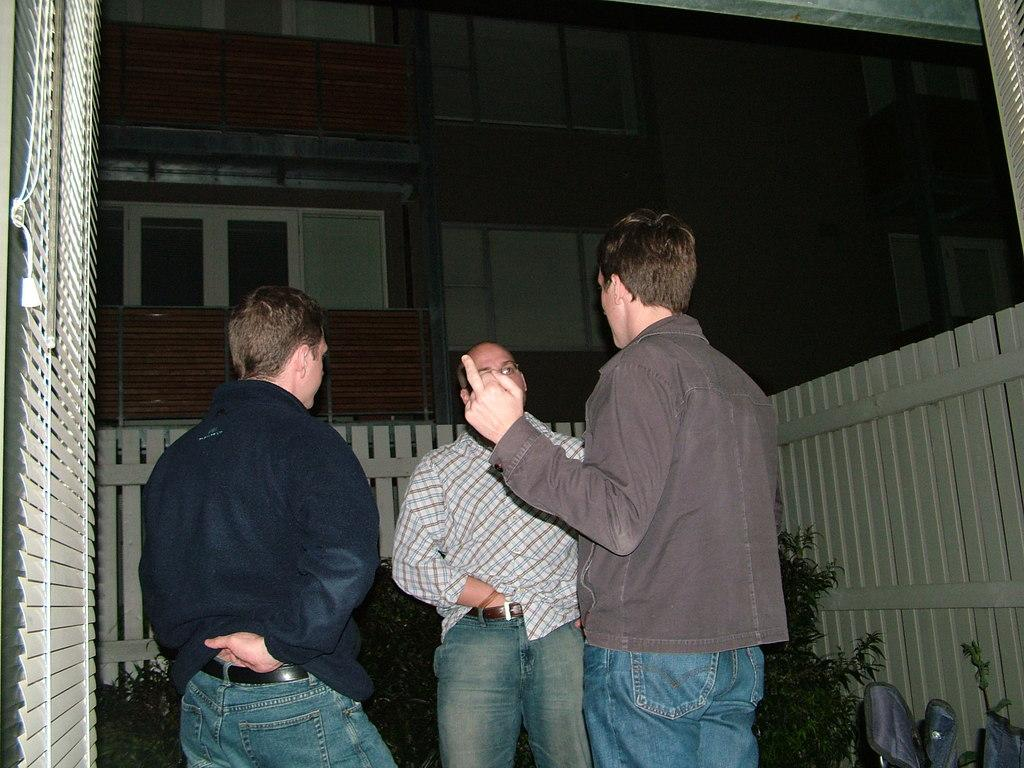How many people are in the image? There are three persons standing in the middle of the image. What can be seen in the background of the image? There are plants and buildings in the background of the image. What color are the eyes of the person on the left in the image? There is no information about the eye color of the persons in the image, as the facts provided do not mention it. 